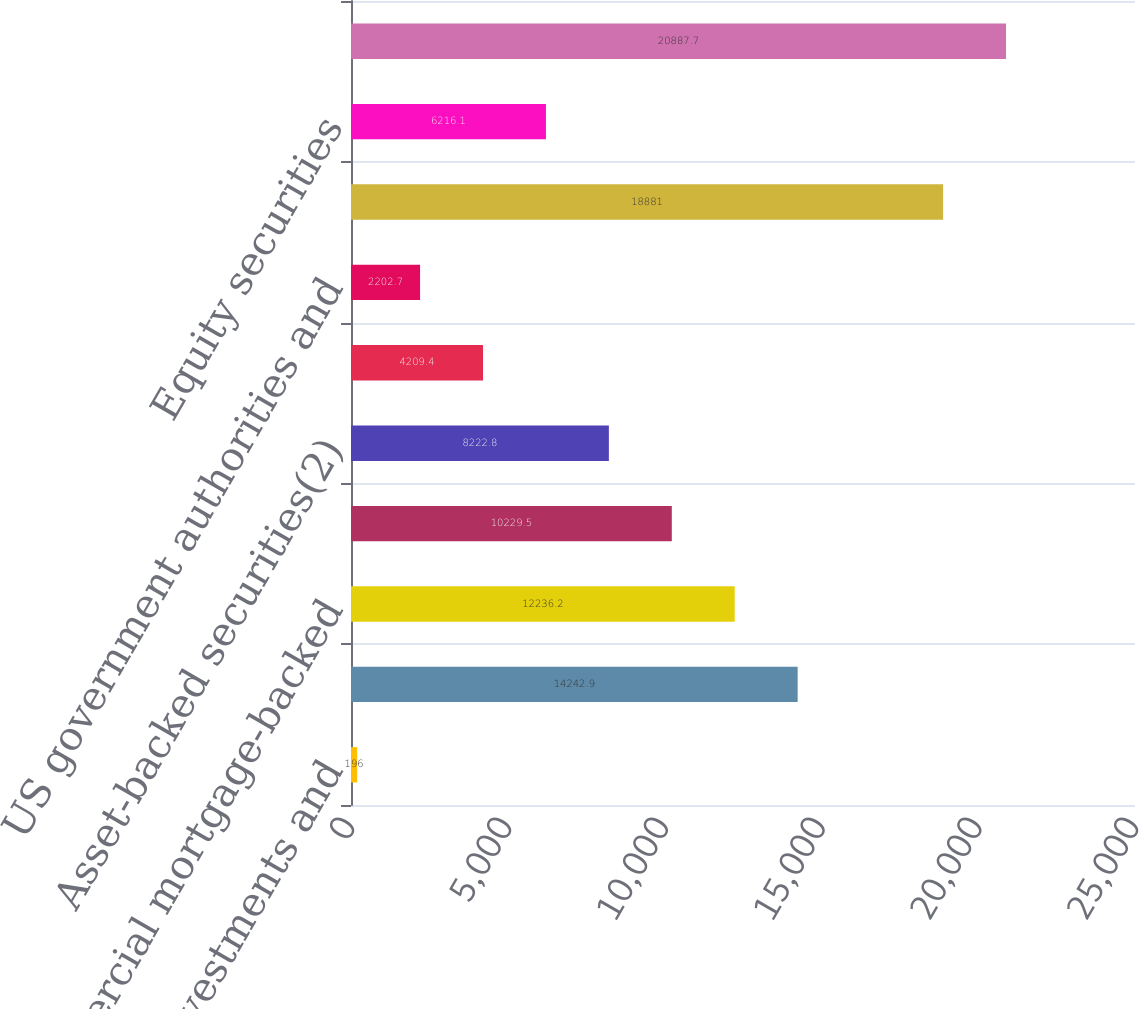Convert chart to OTSL. <chart><loc_0><loc_0><loc_500><loc_500><bar_chart><fcel>Short-term investments and<fcel>Corporate securities<fcel>Commercial mortgage-backed<fcel>Residential mortgage-backed<fcel>Asset-backed securities(2)<fcel>Foreign government bonds<fcel>US government authorities and<fcel>Total fixed maturities<fcel>Equity securities<fcel>Total trading account assets<nl><fcel>196<fcel>14242.9<fcel>12236.2<fcel>10229.5<fcel>8222.8<fcel>4209.4<fcel>2202.7<fcel>18881<fcel>6216.1<fcel>20887.7<nl></chart> 